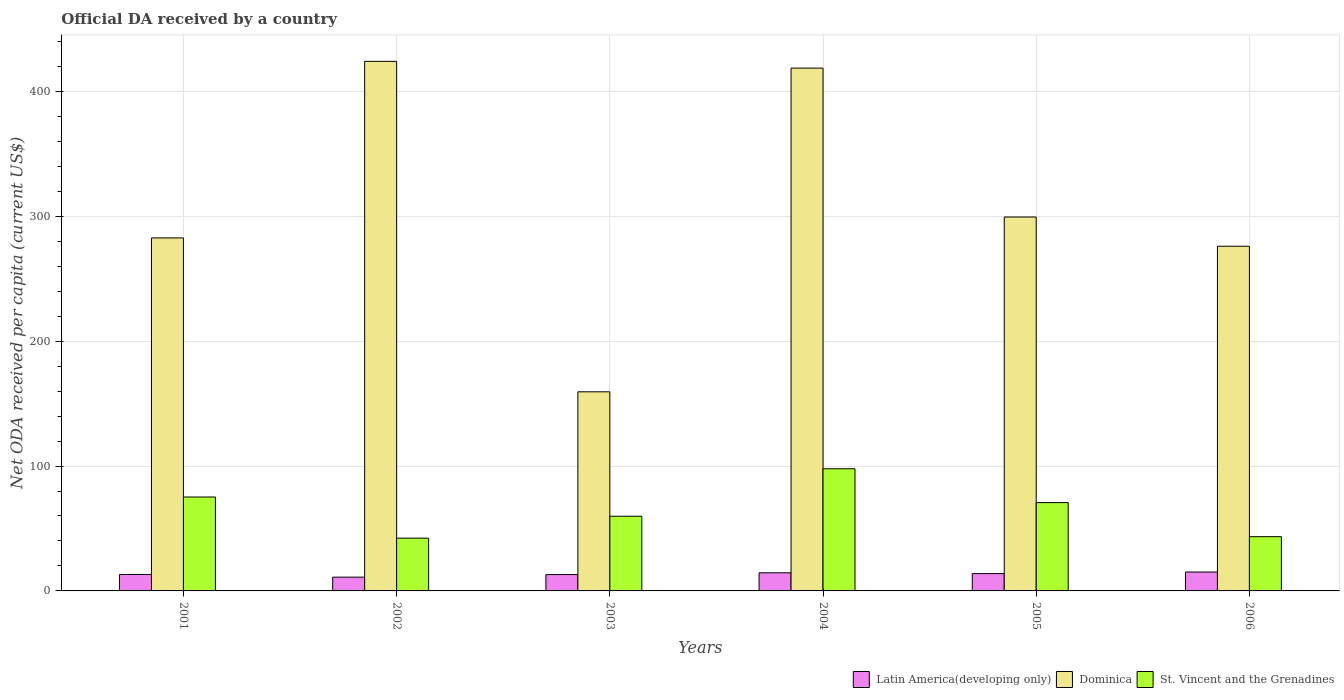Are the number of bars on each tick of the X-axis equal?
Make the answer very short. Yes. What is the label of the 2nd group of bars from the left?
Your response must be concise. 2002. In how many cases, is the number of bars for a given year not equal to the number of legend labels?
Offer a terse response. 0. What is the ODA received in in Latin America(developing only) in 2005?
Ensure brevity in your answer.  13.87. Across all years, what is the maximum ODA received in in Dominica?
Your answer should be very brief. 424.03. Across all years, what is the minimum ODA received in in St. Vincent and the Grenadines?
Ensure brevity in your answer.  42.26. In which year was the ODA received in in Dominica maximum?
Provide a short and direct response. 2002. What is the total ODA received in in Latin America(developing only) in the graph?
Offer a terse response. 80.79. What is the difference between the ODA received in in St. Vincent and the Grenadines in 2003 and that in 2006?
Your response must be concise. 16.37. What is the difference between the ODA received in in Latin America(developing only) in 2005 and the ODA received in in St. Vincent and the Grenadines in 2004?
Offer a terse response. -83.96. What is the average ODA received in in St. Vincent and the Grenadines per year?
Give a very brief answer. 64.87. In the year 2001, what is the difference between the ODA received in in Dominica and ODA received in in Latin America(developing only)?
Provide a short and direct response. 269.5. In how many years, is the ODA received in in Dominica greater than 120 US$?
Offer a very short reply. 6. What is the ratio of the ODA received in in Dominica in 2004 to that in 2005?
Offer a very short reply. 1.4. Is the ODA received in in Dominica in 2002 less than that in 2004?
Keep it short and to the point. No. What is the difference between the highest and the second highest ODA received in in Dominica?
Provide a short and direct response. 5.4. What is the difference between the highest and the lowest ODA received in in Latin America(developing only)?
Make the answer very short. 4.1. In how many years, is the ODA received in in St. Vincent and the Grenadines greater than the average ODA received in in St. Vincent and the Grenadines taken over all years?
Offer a very short reply. 3. What does the 2nd bar from the left in 2006 represents?
Your answer should be very brief. Dominica. What does the 1st bar from the right in 2001 represents?
Provide a succinct answer. St. Vincent and the Grenadines. Are all the bars in the graph horizontal?
Make the answer very short. No. Does the graph contain grids?
Give a very brief answer. Yes. Where does the legend appear in the graph?
Offer a terse response. Bottom right. What is the title of the graph?
Your answer should be very brief. Official DA received by a country. What is the label or title of the Y-axis?
Provide a succinct answer. Net ODA received per capita (current US$). What is the Net ODA received per capita (current US$) of Latin America(developing only) in 2001?
Give a very brief answer. 13.16. What is the Net ODA received per capita (current US$) in Dominica in 2001?
Make the answer very short. 282.66. What is the Net ODA received per capita (current US$) in St. Vincent and the Grenadines in 2001?
Your response must be concise. 75.19. What is the Net ODA received per capita (current US$) of Latin America(developing only) in 2002?
Your response must be concise. 11.03. What is the Net ODA received per capita (current US$) in Dominica in 2002?
Your answer should be compact. 424.03. What is the Net ODA received per capita (current US$) in St. Vincent and the Grenadines in 2002?
Keep it short and to the point. 42.26. What is the Net ODA received per capita (current US$) in Latin America(developing only) in 2003?
Provide a short and direct response. 13.1. What is the Net ODA received per capita (current US$) of Dominica in 2003?
Your answer should be very brief. 159.44. What is the Net ODA received per capita (current US$) of St. Vincent and the Grenadines in 2003?
Provide a short and direct response. 59.8. What is the Net ODA received per capita (current US$) of Latin America(developing only) in 2004?
Provide a succinct answer. 14.51. What is the Net ODA received per capita (current US$) in Dominica in 2004?
Ensure brevity in your answer.  418.63. What is the Net ODA received per capita (current US$) of St. Vincent and the Grenadines in 2004?
Offer a very short reply. 97.82. What is the Net ODA received per capita (current US$) in Latin America(developing only) in 2005?
Keep it short and to the point. 13.87. What is the Net ODA received per capita (current US$) of Dominica in 2005?
Offer a terse response. 299.4. What is the Net ODA received per capita (current US$) of St. Vincent and the Grenadines in 2005?
Make the answer very short. 70.71. What is the Net ODA received per capita (current US$) of Latin America(developing only) in 2006?
Offer a terse response. 15.13. What is the Net ODA received per capita (current US$) in Dominica in 2006?
Provide a short and direct response. 275.99. What is the Net ODA received per capita (current US$) in St. Vincent and the Grenadines in 2006?
Offer a terse response. 43.43. Across all years, what is the maximum Net ODA received per capita (current US$) of Latin America(developing only)?
Your answer should be very brief. 15.13. Across all years, what is the maximum Net ODA received per capita (current US$) in Dominica?
Your response must be concise. 424.03. Across all years, what is the maximum Net ODA received per capita (current US$) in St. Vincent and the Grenadines?
Offer a terse response. 97.82. Across all years, what is the minimum Net ODA received per capita (current US$) in Latin America(developing only)?
Offer a terse response. 11.03. Across all years, what is the minimum Net ODA received per capita (current US$) in Dominica?
Your answer should be very brief. 159.44. Across all years, what is the minimum Net ODA received per capita (current US$) in St. Vincent and the Grenadines?
Give a very brief answer. 42.26. What is the total Net ODA received per capita (current US$) in Latin America(developing only) in the graph?
Ensure brevity in your answer.  80.79. What is the total Net ODA received per capita (current US$) in Dominica in the graph?
Your answer should be very brief. 1860.15. What is the total Net ODA received per capita (current US$) in St. Vincent and the Grenadines in the graph?
Keep it short and to the point. 389.22. What is the difference between the Net ODA received per capita (current US$) of Latin America(developing only) in 2001 and that in 2002?
Provide a succinct answer. 2.13. What is the difference between the Net ODA received per capita (current US$) of Dominica in 2001 and that in 2002?
Keep it short and to the point. -141.37. What is the difference between the Net ODA received per capita (current US$) in St. Vincent and the Grenadines in 2001 and that in 2002?
Offer a terse response. 32.94. What is the difference between the Net ODA received per capita (current US$) of Latin America(developing only) in 2001 and that in 2003?
Offer a very short reply. 0.06. What is the difference between the Net ODA received per capita (current US$) of Dominica in 2001 and that in 2003?
Your response must be concise. 123.22. What is the difference between the Net ODA received per capita (current US$) in St. Vincent and the Grenadines in 2001 and that in 2003?
Keep it short and to the point. 15.39. What is the difference between the Net ODA received per capita (current US$) of Latin America(developing only) in 2001 and that in 2004?
Ensure brevity in your answer.  -1.36. What is the difference between the Net ODA received per capita (current US$) in Dominica in 2001 and that in 2004?
Offer a very short reply. -135.97. What is the difference between the Net ODA received per capita (current US$) of St. Vincent and the Grenadines in 2001 and that in 2004?
Give a very brief answer. -22.63. What is the difference between the Net ODA received per capita (current US$) in Latin America(developing only) in 2001 and that in 2005?
Your answer should be very brief. -0.71. What is the difference between the Net ODA received per capita (current US$) of Dominica in 2001 and that in 2005?
Ensure brevity in your answer.  -16.74. What is the difference between the Net ODA received per capita (current US$) of St. Vincent and the Grenadines in 2001 and that in 2005?
Your response must be concise. 4.48. What is the difference between the Net ODA received per capita (current US$) of Latin America(developing only) in 2001 and that in 2006?
Keep it short and to the point. -1.98. What is the difference between the Net ODA received per capita (current US$) of Dominica in 2001 and that in 2006?
Ensure brevity in your answer.  6.66. What is the difference between the Net ODA received per capita (current US$) in St. Vincent and the Grenadines in 2001 and that in 2006?
Your answer should be very brief. 31.76. What is the difference between the Net ODA received per capita (current US$) of Latin America(developing only) in 2002 and that in 2003?
Provide a succinct answer. -2.07. What is the difference between the Net ODA received per capita (current US$) of Dominica in 2002 and that in 2003?
Make the answer very short. 264.59. What is the difference between the Net ODA received per capita (current US$) of St. Vincent and the Grenadines in 2002 and that in 2003?
Provide a succinct answer. -17.55. What is the difference between the Net ODA received per capita (current US$) of Latin America(developing only) in 2002 and that in 2004?
Offer a terse response. -3.48. What is the difference between the Net ODA received per capita (current US$) in Dominica in 2002 and that in 2004?
Keep it short and to the point. 5.4. What is the difference between the Net ODA received per capita (current US$) in St. Vincent and the Grenadines in 2002 and that in 2004?
Your response must be concise. -55.57. What is the difference between the Net ODA received per capita (current US$) of Latin America(developing only) in 2002 and that in 2005?
Give a very brief answer. -2.84. What is the difference between the Net ODA received per capita (current US$) in Dominica in 2002 and that in 2005?
Give a very brief answer. 124.64. What is the difference between the Net ODA received per capita (current US$) in St. Vincent and the Grenadines in 2002 and that in 2005?
Your response must be concise. -28.46. What is the difference between the Net ODA received per capita (current US$) in Latin America(developing only) in 2002 and that in 2006?
Your answer should be compact. -4.1. What is the difference between the Net ODA received per capita (current US$) of Dominica in 2002 and that in 2006?
Provide a succinct answer. 148.04. What is the difference between the Net ODA received per capita (current US$) in St. Vincent and the Grenadines in 2002 and that in 2006?
Your answer should be very brief. -1.18. What is the difference between the Net ODA received per capita (current US$) in Latin America(developing only) in 2003 and that in 2004?
Keep it short and to the point. -1.41. What is the difference between the Net ODA received per capita (current US$) in Dominica in 2003 and that in 2004?
Offer a terse response. -259.19. What is the difference between the Net ODA received per capita (current US$) of St. Vincent and the Grenadines in 2003 and that in 2004?
Provide a succinct answer. -38.02. What is the difference between the Net ODA received per capita (current US$) of Latin America(developing only) in 2003 and that in 2005?
Offer a terse response. -0.77. What is the difference between the Net ODA received per capita (current US$) in Dominica in 2003 and that in 2005?
Give a very brief answer. -139.96. What is the difference between the Net ODA received per capita (current US$) of St. Vincent and the Grenadines in 2003 and that in 2005?
Your answer should be very brief. -10.91. What is the difference between the Net ODA received per capita (current US$) of Latin America(developing only) in 2003 and that in 2006?
Your response must be concise. -2.03. What is the difference between the Net ODA received per capita (current US$) in Dominica in 2003 and that in 2006?
Ensure brevity in your answer.  -116.55. What is the difference between the Net ODA received per capita (current US$) in St. Vincent and the Grenadines in 2003 and that in 2006?
Provide a succinct answer. 16.37. What is the difference between the Net ODA received per capita (current US$) of Latin America(developing only) in 2004 and that in 2005?
Your response must be concise. 0.64. What is the difference between the Net ODA received per capita (current US$) of Dominica in 2004 and that in 2005?
Your answer should be compact. 119.23. What is the difference between the Net ODA received per capita (current US$) of St. Vincent and the Grenadines in 2004 and that in 2005?
Offer a terse response. 27.11. What is the difference between the Net ODA received per capita (current US$) of Latin America(developing only) in 2004 and that in 2006?
Ensure brevity in your answer.  -0.62. What is the difference between the Net ODA received per capita (current US$) of Dominica in 2004 and that in 2006?
Provide a succinct answer. 142.63. What is the difference between the Net ODA received per capita (current US$) of St. Vincent and the Grenadines in 2004 and that in 2006?
Your response must be concise. 54.39. What is the difference between the Net ODA received per capita (current US$) in Latin America(developing only) in 2005 and that in 2006?
Keep it short and to the point. -1.26. What is the difference between the Net ODA received per capita (current US$) of Dominica in 2005 and that in 2006?
Your answer should be compact. 23.4. What is the difference between the Net ODA received per capita (current US$) in St. Vincent and the Grenadines in 2005 and that in 2006?
Make the answer very short. 27.28. What is the difference between the Net ODA received per capita (current US$) of Latin America(developing only) in 2001 and the Net ODA received per capita (current US$) of Dominica in 2002?
Your answer should be compact. -410.88. What is the difference between the Net ODA received per capita (current US$) in Latin America(developing only) in 2001 and the Net ODA received per capita (current US$) in St. Vincent and the Grenadines in 2002?
Your answer should be very brief. -29.1. What is the difference between the Net ODA received per capita (current US$) in Dominica in 2001 and the Net ODA received per capita (current US$) in St. Vincent and the Grenadines in 2002?
Provide a succinct answer. 240.4. What is the difference between the Net ODA received per capita (current US$) of Latin America(developing only) in 2001 and the Net ODA received per capita (current US$) of Dominica in 2003?
Offer a very short reply. -146.28. What is the difference between the Net ODA received per capita (current US$) of Latin America(developing only) in 2001 and the Net ODA received per capita (current US$) of St. Vincent and the Grenadines in 2003?
Your answer should be compact. -46.65. What is the difference between the Net ODA received per capita (current US$) of Dominica in 2001 and the Net ODA received per capita (current US$) of St. Vincent and the Grenadines in 2003?
Keep it short and to the point. 222.85. What is the difference between the Net ODA received per capita (current US$) in Latin America(developing only) in 2001 and the Net ODA received per capita (current US$) in Dominica in 2004?
Your answer should be very brief. -405.47. What is the difference between the Net ODA received per capita (current US$) in Latin America(developing only) in 2001 and the Net ODA received per capita (current US$) in St. Vincent and the Grenadines in 2004?
Your answer should be compact. -84.67. What is the difference between the Net ODA received per capita (current US$) of Dominica in 2001 and the Net ODA received per capita (current US$) of St. Vincent and the Grenadines in 2004?
Offer a very short reply. 184.84. What is the difference between the Net ODA received per capita (current US$) in Latin America(developing only) in 2001 and the Net ODA received per capita (current US$) in Dominica in 2005?
Your answer should be very brief. -286.24. What is the difference between the Net ODA received per capita (current US$) of Latin America(developing only) in 2001 and the Net ODA received per capita (current US$) of St. Vincent and the Grenadines in 2005?
Your answer should be compact. -57.56. What is the difference between the Net ODA received per capita (current US$) of Dominica in 2001 and the Net ODA received per capita (current US$) of St. Vincent and the Grenadines in 2005?
Provide a short and direct response. 211.95. What is the difference between the Net ODA received per capita (current US$) in Latin America(developing only) in 2001 and the Net ODA received per capita (current US$) in Dominica in 2006?
Your answer should be compact. -262.84. What is the difference between the Net ODA received per capita (current US$) of Latin America(developing only) in 2001 and the Net ODA received per capita (current US$) of St. Vincent and the Grenadines in 2006?
Your response must be concise. -30.28. What is the difference between the Net ODA received per capita (current US$) of Dominica in 2001 and the Net ODA received per capita (current US$) of St. Vincent and the Grenadines in 2006?
Keep it short and to the point. 239.23. What is the difference between the Net ODA received per capita (current US$) of Latin America(developing only) in 2002 and the Net ODA received per capita (current US$) of Dominica in 2003?
Offer a very short reply. -148.41. What is the difference between the Net ODA received per capita (current US$) in Latin America(developing only) in 2002 and the Net ODA received per capita (current US$) in St. Vincent and the Grenadines in 2003?
Your response must be concise. -48.78. What is the difference between the Net ODA received per capita (current US$) of Dominica in 2002 and the Net ODA received per capita (current US$) of St. Vincent and the Grenadines in 2003?
Offer a terse response. 364.23. What is the difference between the Net ODA received per capita (current US$) in Latin America(developing only) in 2002 and the Net ODA received per capita (current US$) in Dominica in 2004?
Your response must be concise. -407.6. What is the difference between the Net ODA received per capita (current US$) in Latin America(developing only) in 2002 and the Net ODA received per capita (current US$) in St. Vincent and the Grenadines in 2004?
Your response must be concise. -86.8. What is the difference between the Net ODA received per capita (current US$) of Dominica in 2002 and the Net ODA received per capita (current US$) of St. Vincent and the Grenadines in 2004?
Your answer should be very brief. 326.21. What is the difference between the Net ODA received per capita (current US$) in Latin America(developing only) in 2002 and the Net ODA received per capita (current US$) in Dominica in 2005?
Ensure brevity in your answer.  -288.37. What is the difference between the Net ODA received per capita (current US$) in Latin America(developing only) in 2002 and the Net ODA received per capita (current US$) in St. Vincent and the Grenadines in 2005?
Provide a short and direct response. -59.69. What is the difference between the Net ODA received per capita (current US$) in Dominica in 2002 and the Net ODA received per capita (current US$) in St. Vincent and the Grenadines in 2005?
Keep it short and to the point. 353.32. What is the difference between the Net ODA received per capita (current US$) of Latin America(developing only) in 2002 and the Net ODA received per capita (current US$) of Dominica in 2006?
Give a very brief answer. -264.97. What is the difference between the Net ODA received per capita (current US$) of Latin America(developing only) in 2002 and the Net ODA received per capita (current US$) of St. Vincent and the Grenadines in 2006?
Offer a very short reply. -32.4. What is the difference between the Net ODA received per capita (current US$) in Dominica in 2002 and the Net ODA received per capita (current US$) in St. Vincent and the Grenadines in 2006?
Offer a very short reply. 380.6. What is the difference between the Net ODA received per capita (current US$) in Latin America(developing only) in 2003 and the Net ODA received per capita (current US$) in Dominica in 2004?
Offer a very short reply. -405.53. What is the difference between the Net ODA received per capita (current US$) of Latin America(developing only) in 2003 and the Net ODA received per capita (current US$) of St. Vincent and the Grenadines in 2004?
Offer a terse response. -84.73. What is the difference between the Net ODA received per capita (current US$) in Dominica in 2003 and the Net ODA received per capita (current US$) in St. Vincent and the Grenadines in 2004?
Your response must be concise. 61.62. What is the difference between the Net ODA received per capita (current US$) in Latin America(developing only) in 2003 and the Net ODA received per capita (current US$) in Dominica in 2005?
Ensure brevity in your answer.  -286.3. What is the difference between the Net ODA received per capita (current US$) in Latin America(developing only) in 2003 and the Net ODA received per capita (current US$) in St. Vincent and the Grenadines in 2005?
Offer a very short reply. -57.62. What is the difference between the Net ODA received per capita (current US$) in Dominica in 2003 and the Net ODA received per capita (current US$) in St. Vincent and the Grenadines in 2005?
Your answer should be compact. 88.73. What is the difference between the Net ODA received per capita (current US$) of Latin America(developing only) in 2003 and the Net ODA received per capita (current US$) of Dominica in 2006?
Provide a succinct answer. -262.9. What is the difference between the Net ODA received per capita (current US$) of Latin America(developing only) in 2003 and the Net ODA received per capita (current US$) of St. Vincent and the Grenadines in 2006?
Your answer should be very brief. -30.33. What is the difference between the Net ODA received per capita (current US$) in Dominica in 2003 and the Net ODA received per capita (current US$) in St. Vincent and the Grenadines in 2006?
Your answer should be compact. 116.01. What is the difference between the Net ODA received per capita (current US$) of Latin America(developing only) in 2004 and the Net ODA received per capita (current US$) of Dominica in 2005?
Provide a short and direct response. -284.88. What is the difference between the Net ODA received per capita (current US$) of Latin America(developing only) in 2004 and the Net ODA received per capita (current US$) of St. Vincent and the Grenadines in 2005?
Offer a terse response. -56.2. What is the difference between the Net ODA received per capita (current US$) of Dominica in 2004 and the Net ODA received per capita (current US$) of St. Vincent and the Grenadines in 2005?
Your response must be concise. 347.91. What is the difference between the Net ODA received per capita (current US$) of Latin America(developing only) in 2004 and the Net ODA received per capita (current US$) of Dominica in 2006?
Provide a succinct answer. -261.48. What is the difference between the Net ODA received per capita (current US$) of Latin America(developing only) in 2004 and the Net ODA received per capita (current US$) of St. Vincent and the Grenadines in 2006?
Provide a short and direct response. -28.92. What is the difference between the Net ODA received per capita (current US$) of Dominica in 2004 and the Net ODA received per capita (current US$) of St. Vincent and the Grenadines in 2006?
Your response must be concise. 375.2. What is the difference between the Net ODA received per capita (current US$) of Latin America(developing only) in 2005 and the Net ODA received per capita (current US$) of Dominica in 2006?
Your answer should be compact. -262.13. What is the difference between the Net ODA received per capita (current US$) of Latin America(developing only) in 2005 and the Net ODA received per capita (current US$) of St. Vincent and the Grenadines in 2006?
Your answer should be compact. -29.56. What is the difference between the Net ODA received per capita (current US$) in Dominica in 2005 and the Net ODA received per capita (current US$) in St. Vincent and the Grenadines in 2006?
Provide a short and direct response. 255.97. What is the average Net ODA received per capita (current US$) in Latin America(developing only) per year?
Give a very brief answer. 13.46. What is the average Net ODA received per capita (current US$) of Dominica per year?
Offer a terse response. 310.02. What is the average Net ODA received per capita (current US$) of St. Vincent and the Grenadines per year?
Ensure brevity in your answer.  64.87. In the year 2001, what is the difference between the Net ODA received per capita (current US$) in Latin America(developing only) and Net ODA received per capita (current US$) in Dominica?
Offer a terse response. -269.5. In the year 2001, what is the difference between the Net ODA received per capita (current US$) in Latin America(developing only) and Net ODA received per capita (current US$) in St. Vincent and the Grenadines?
Provide a short and direct response. -62.04. In the year 2001, what is the difference between the Net ODA received per capita (current US$) in Dominica and Net ODA received per capita (current US$) in St. Vincent and the Grenadines?
Ensure brevity in your answer.  207.47. In the year 2002, what is the difference between the Net ODA received per capita (current US$) in Latin America(developing only) and Net ODA received per capita (current US$) in Dominica?
Make the answer very short. -413.01. In the year 2002, what is the difference between the Net ODA received per capita (current US$) in Latin America(developing only) and Net ODA received per capita (current US$) in St. Vincent and the Grenadines?
Ensure brevity in your answer.  -31.23. In the year 2002, what is the difference between the Net ODA received per capita (current US$) in Dominica and Net ODA received per capita (current US$) in St. Vincent and the Grenadines?
Offer a terse response. 381.78. In the year 2003, what is the difference between the Net ODA received per capita (current US$) in Latin America(developing only) and Net ODA received per capita (current US$) in Dominica?
Offer a terse response. -146.34. In the year 2003, what is the difference between the Net ODA received per capita (current US$) of Latin America(developing only) and Net ODA received per capita (current US$) of St. Vincent and the Grenadines?
Offer a very short reply. -46.71. In the year 2003, what is the difference between the Net ODA received per capita (current US$) of Dominica and Net ODA received per capita (current US$) of St. Vincent and the Grenadines?
Make the answer very short. 99.64. In the year 2004, what is the difference between the Net ODA received per capita (current US$) in Latin America(developing only) and Net ODA received per capita (current US$) in Dominica?
Keep it short and to the point. -404.12. In the year 2004, what is the difference between the Net ODA received per capita (current US$) in Latin America(developing only) and Net ODA received per capita (current US$) in St. Vincent and the Grenadines?
Your answer should be compact. -83.31. In the year 2004, what is the difference between the Net ODA received per capita (current US$) of Dominica and Net ODA received per capita (current US$) of St. Vincent and the Grenadines?
Give a very brief answer. 320.8. In the year 2005, what is the difference between the Net ODA received per capita (current US$) of Latin America(developing only) and Net ODA received per capita (current US$) of Dominica?
Your response must be concise. -285.53. In the year 2005, what is the difference between the Net ODA received per capita (current US$) of Latin America(developing only) and Net ODA received per capita (current US$) of St. Vincent and the Grenadines?
Make the answer very short. -56.85. In the year 2005, what is the difference between the Net ODA received per capita (current US$) in Dominica and Net ODA received per capita (current US$) in St. Vincent and the Grenadines?
Your answer should be compact. 228.68. In the year 2006, what is the difference between the Net ODA received per capita (current US$) in Latin America(developing only) and Net ODA received per capita (current US$) in Dominica?
Ensure brevity in your answer.  -260.86. In the year 2006, what is the difference between the Net ODA received per capita (current US$) in Latin America(developing only) and Net ODA received per capita (current US$) in St. Vincent and the Grenadines?
Offer a very short reply. -28.3. In the year 2006, what is the difference between the Net ODA received per capita (current US$) of Dominica and Net ODA received per capita (current US$) of St. Vincent and the Grenadines?
Offer a terse response. 232.56. What is the ratio of the Net ODA received per capita (current US$) of Latin America(developing only) in 2001 to that in 2002?
Provide a short and direct response. 1.19. What is the ratio of the Net ODA received per capita (current US$) in Dominica in 2001 to that in 2002?
Provide a short and direct response. 0.67. What is the ratio of the Net ODA received per capita (current US$) in St. Vincent and the Grenadines in 2001 to that in 2002?
Your answer should be compact. 1.78. What is the ratio of the Net ODA received per capita (current US$) in Dominica in 2001 to that in 2003?
Provide a short and direct response. 1.77. What is the ratio of the Net ODA received per capita (current US$) in St. Vincent and the Grenadines in 2001 to that in 2003?
Make the answer very short. 1.26. What is the ratio of the Net ODA received per capita (current US$) in Latin America(developing only) in 2001 to that in 2004?
Keep it short and to the point. 0.91. What is the ratio of the Net ODA received per capita (current US$) of Dominica in 2001 to that in 2004?
Give a very brief answer. 0.68. What is the ratio of the Net ODA received per capita (current US$) in St. Vincent and the Grenadines in 2001 to that in 2004?
Your response must be concise. 0.77. What is the ratio of the Net ODA received per capita (current US$) in Latin America(developing only) in 2001 to that in 2005?
Give a very brief answer. 0.95. What is the ratio of the Net ODA received per capita (current US$) of Dominica in 2001 to that in 2005?
Your answer should be compact. 0.94. What is the ratio of the Net ODA received per capita (current US$) of St. Vincent and the Grenadines in 2001 to that in 2005?
Your response must be concise. 1.06. What is the ratio of the Net ODA received per capita (current US$) in Latin America(developing only) in 2001 to that in 2006?
Make the answer very short. 0.87. What is the ratio of the Net ODA received per capita (current US$) in Dominica in 2001 to that in 2006?
Ensure brevity in your answer.  1.02. What is the ratio of the Net ODA received per capita (current US$) in St. Vincent and the Grenadines in 2001 to that in 2006?
Offer a very short reply. 1.73. What is the ratio of the Net ODA received per capita (current US$) of Latin America(developing only) in 2002 to that in 2003?
Your answer should be compact. 0.84. What is the ratio of the Net ODA received per capita (current US$) of Dominica in 2002 to that in 2003?
Provide a succinct answer. 2.66. What is the ratio of the Net ODA received per capita (current US$) of St. Vincent and the Grenadines in 2002 to that in 2003?
Your answer should be very brief. 0.71. What is the ratio of the Net ODA received per capita (current US$) in Latin America(developing only) in 2002 to that in 2004?
Your response must be concise. 0.76. What is the ratio of the Net ODA received per capita (current US$) in Dominica in 2002 to that in 2004?
Keep it short and to the point. 1.01. What is the ratio of the Net ODA received per capita (current US$) in St. Vincent and the Grenadines in 2002 to that in 2004?
Offer a terse response. 0.43. What is the ratio of the Net ODA received per capita (current US$) of Latin America(developing only) in 2002 to that in 2005?
Your response must be concise. 0.8. What is the ratio of the Net ODA received per capita (current US$) of Dominica in 2002 to that in 2005?
Give a very brief answer. 1.42. What is the ratio of the Net ODA received per capita (current US$) in St. Vincent and the Grenadines in 2002 to that in 2005?
Your answer should be compact. 0.6. What is the ratio of the Net ODA received per capita (current US$) in Latin America(developing only) in 2002 to that in 2006?
Your answer should be compact. 0.73. What is the ratio of the Net ODA received per capita (current US$) in Dominica in 2002 to that in 2006?
Provide a short and direct response. 1.54. What is the ratio of the Net ODA received per capita (current US$) in St. Vincent and the Grenadines in 2002 to that in 2006?
Give a very brief answer. 0.97. What is the ratio of the Net ODA received per capita (current US$) in Latin America(developing only) in 2003 to that in 2004?
Your response must be concise. 0.9. What is the ratio of the Net ODA received per capita (current US$) in Dominica in 2003 to that in 2004?
Your answer should be very brief. 0.38. What is the ratio of the Net ODA received per capita (current US$) in St. Vincent and the Grenadines in 2003 to that in 2004?
Make the answer very short. 0.61. What is the ratio of the Net ODA received per capita (current US$) of Latin America(developing only) in 2003 to that in 2005?
Your response must be concise. 0.94. What is the ratio of the Net ODA received per capita (current US$) in Dominica in 2003 to that in 2005?
Make the answer very short. 0.53. What is the ratio of the Net ODA received per capita (current US$) of St. Vincent and the Grenadines in 2003 to that in 2005?
Offer a very short reply. 0.85. What is the ratio of the Net ODA received per capita (current US$) of Latin America(developing only) in 2003 to that in 2006?
Make the answer very short. 0.87. What is the ratio of the Net ODA received per capita (current US$) of Dominica in 2003 to that in 2006?
Provide a short and direct response. 0.58. What is the ratio of the Net ODA received per capita (current US$) of St. Vincent and the Grenadines in 2003 to that in 2006?
Your response must be concise. 1.38. What is the ratio of the Net ODA received per capita (current US$) in Latin America(developing only) in 2004 to that in 2005?
Provide a succinct answer. 1.05. What is the ratio of the Net ODA received per capita (current US$) in Dominica in 2004 to that in 2005?
Provide a succinct answer. 1.4. What is the ratio of the Net ODA received per capita (current US$) of St. Vincent and the Grenadines in 2004 to that in 2005?
Make the answer very short. 1.38. What is the ratio of the Net ODA received per capita (current US$) of Latin America(developing only) in 2004 to that in 2006?
Ensure brevity in your answer.  0.96. What is the ratio of the Net ODA received per capita (current US$) of Dominica in 2004 to that in 2006?
Offer a very short reply. 1.52. What is the ratio of the Net ODA received per capita (current US$) of St. Vincent and the Grenadines in 2004 to that in 2006?
Your response must be concise. 2.25. What is the ratio of the Net ODA received per capita (current US$) in Latin America(developing only) in 2005 to that in 2006?
Offer a very short reply. 0.92. What is the ratio of the Net ODA received per capita (current US$) of Dominica in 2005 to that in 2006?
Provide a succinct answer. 1.08. What is the ratio of the Net ODA received per capita (current US$) in St. Vincent and the Grenadines in 2005 to that in 2006?
Provide a succinct answer. 1.63. What is the difference between the highest and the second highest Net ODA received per capita (current US$) of Latin America(developing only)?
Your answer should be compact. 0.62. What is the difference between the highest and the second highest Net ODA received per capita (current US$) in Dominica?
Offer a very short reply. 5.4. What is the difference between the highest and the second highest Net ODA received per capita (current US$) of St. Vincent and the Grenadines?
Offer a terse response. 22.63. What is the difference between the highest and the lowest Net ODA received per capita (current US$) of Latin America(developing only)?
Your answer should be compact. 4.1. What is the difference between the highest and the lowest Net ODA received per capita (current US$) in Dominica?
Offer a very short reply. 264.59. What is the difference between the highest and the lowest Net ODA received per capita (current US$) of St. Vincent and the Grenadines?
Give a very brief answer. 55.57. 